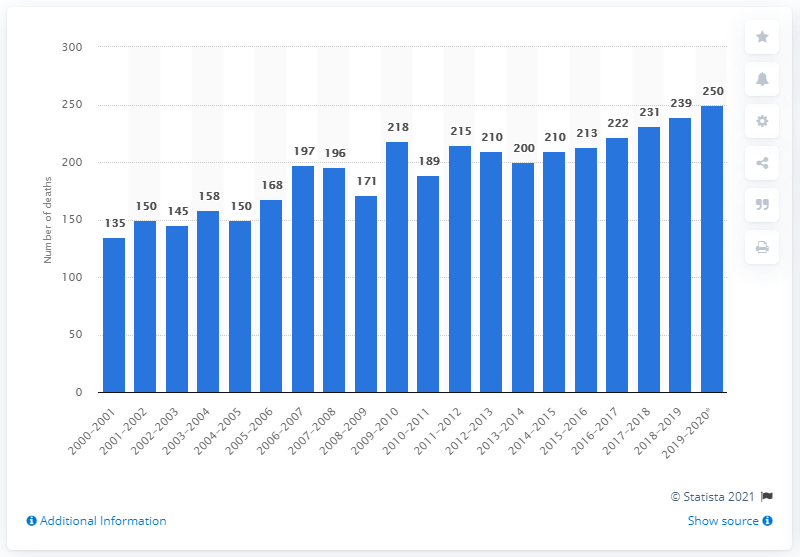Identify some key points in this picture. During the period of July 1, 2019 and June 30, 2020, an estimated 250 individuals died in Yukon. 